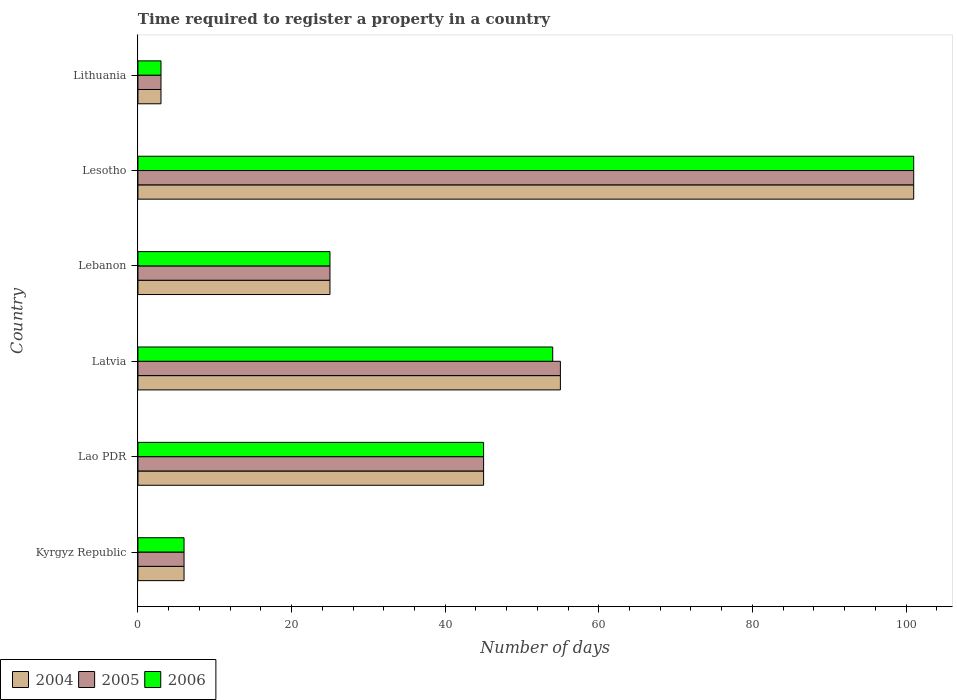How many different coloured bars are there?
Provide a short and direct response. 3. Are the number of bars per tick equal to the number of legend labels?
Offer a very short reply. Yes. Are the number of bars on each tick of the Y-axis equal?
Your response must be concise. Yes. How many bars are there on the 2nd tick from the bottom?
Give a very brief answer. 3. What is the label of the 2nd group of bars from the top?
Your answer should be very brief. Lesotho. In how many cases, is the number of bars for a given country not equal to the number of legend labels?
Give a very brief answer. 0. Across all countries, what is the maximum number of days required to register a property in 2006?
Make the answer very short. 101. Across all countries, what is the minimum number of days required to register a property in 2005?
Keep it short and to the point. 3. In which country was the number of days required to register a property in 2004 maximum?
Give a very brief answer. Lesotho. In which country was the number of days required to register a property in 2005 minimum?
Make the answer very short. Lithuania. What is the total number of days required to register a property in 2005 in the graph?
Offer a terse response. 235. What is the difference between the number of days required to register a property in 2005 in Lithuania and the number of days required to register a property in 2004 in Latvia?
Give a very brief answer. -52. What is the average number of days required to register a property in 2004 per country?
Your answer should be very brief. 39.17. What is the difference between the number of days required to register a property in 2006 and number of days required to register a property in 2004 in Latvia?
Provide a short and direct response. -1. Is the number of days required to register a property in 2004 in Latvia less than that in Lithuania?
Keep it short and to the point. No. Is the difference between the number of days required to register a property in 2006 in Kyrgyz Republic and Lao PDR greater than the difference between the number of days required to register a property in 2004 in Kyrgyz Republic and Lao PDR?
Ensure brevity in your answer.  No. In how many countries, is the number of days required to register a property in 2006 greater than the average number of days required to register a property in 2006 taken over all countries?
Provide a short and direct response. 3. Is the sum of the number of days required to register a property in 2005 in Lao PDR and Latvia greater than the maximum number of days required to register a property in 2006 across all countries?
Give a very brief answer. No. What does the 1st bar from the top in Lesotho represents?
Keep it short and to the point. 2006. What does the 1st bar from the bottom in Lesotho represents?
Offer a very short reply. 2004. How many bars are there?
Keep it short and to the point. 18. Are all the bars in the graph horizontal?
Your answer should be compact. Yes. How many countries are there in the graph?
Give a very brief answer. 6. Does the graph contain any zero values?
Provide a succinct answer. No. Does the graph contain grids?
Your response must be concise. No. How many legend labels are there?
Provide a succinct answer. 3. What is the title of the graph?
Your answer should be very brief. Time required to register a property in a country. Does "2009" appear as one of the legend labels in the graph?
Your response must be concise. No. What is the label or title of the X-axis?
Make the answer very short. Number of days. What is the Number of days of 2004 in Kyrgyz Republic?
Offer a very short reply. 6. What is the Number of days in 2005 in Kyrgyz Republic?
Provide a succinct answer. 6. What is the Number of days of 2006 in Lao PDR?
Provide a short and direct response. 45. What is the Number of days in 2006 in Latvia?
Your response must be concise. 54. What is the Number of days of 2005 in Lebanon?
Provide a succinct answer. 25. What is the Number of days of 2004 in Lesotho?
Your response must be concise. 101. What is the Number of days of 2005 in Lesotho?
Provide a succinct answer. 101. What is the Number of days of 2006 in Lesotho?
Provide a succinct answer. 101. What is the Number of days in 2005 in Lithuania?
Provide a short and direct response. 3. Across all countries, what is the maximum Number of days of 2004?
Ensure brevity in your answer.  101. Across all countries, what is the maximum Number of days in 2005?
Provide a succinct answer. 101. Across all countries, what is the maximum Number of days in 2006?
Your response must be concise. 101. Across all countries, what is the minimum Number of days of 2005?
Your response must be concise. 3. What is the total Number of days in 2004 in the graph?
Provide a short and direct response. 235. What is the total Number of days in 2005 in the graph?
Give a very brief answer. 235. What is the total Number of days of 2006 in the graph?
Keep it short and to the point. 234. What is the difference between the Number of days in 2004 in Kyrgyz Republic and that in Lao PDR?
Offer a very short reply. -39. What is the difference between the Number of days of 2005 in Kyrgyz Republic and that in Lao PDR?
Ensure brevity in your answer.  -39. What is the difference between the Number of days in 2006 in Kyrgyz Republic and that in Lao PDR?
Keep it short and to the point. -39. What is the difference between the Number of days in 2004 in Kyrgyz Republic and that in Latvia?
Offer a very short reply. -49. What is the difference between the Number of days of 2005 in Kyrgyz Republic and that in Latvia?
Provide a short and direct response. -49. What is the difference between the Number of days of 2006 in Kyrgyz Republic and that in Latvia?
Offer a very short reply. -48. What is the difference between the Number of days of 2004 in Kyrgyz Republic and that in Lebanon?
Offer a terse response. -19. What is the difference between the Number of days in 2005 in Kyrgyz Republic and that in Lebanon?
Your response must be concise. -19. What is the difference between the Number of days in 2004 in Kyrgyz Republic and that in Lesotho?
Your answer should be compact. -95. What is the difference between the Number of days in 2005 in Kyrgyz Republic and that in Lesotho?
Give a very brief answer. -95. What is the difference between the Number of days in 2006 in Kyrgyz Republic and that in Lesotho?
Offer a very short reply. -95. What is the difference between the Number of days of 2004 in Kyrgyz Republic and that in Lithuania?
Make the answer very short. 3. What is the difference between the Number of days in 2005 in Kyrgyz Republic and that in Lithuania?
Offer a very short reply. 3. What is the difference between the Number of days in 2006 in Lao PDR and that in Latvia?
Your answer should be very brief. -9. What is the difference between the Number of days in 2005 in Lao PDR and that in Lebanon?
Offer a very short reply. 20. What is the difference between the Number of days of 2004 in Lao PDR and that in Lesotho?
Ensure brevity in your answer.  -56. What is the difference between the Number of days of 2005 in Lao PDR and that in Lesotho?
Give a very brief answer. -56. What is the difference between the Number of days in 2006 in Lao PDR and that in Lesotho?
Provide a succinct answer. -56. What is the difference between the Number of days in 2006 in Lao PDR and that in Lithuania?
Offer a very short reply. 42. What is the difference between the Number of days in 2005 in Latvia and that in Lebanon?
Ensure brevity in your answer.  30. What is the difference between the Number of days of 2004 in Latvia and that in Lesotho?
Ensure brevity in your answer.  -46. What is the difference between the Number of days in 2005 in Latvia and that in Lesotho?
Your answer should be compact. -46. What is the difference between the Number of days in 2006 in Latvia and that in Lesotho?
Keep it short and to the point. -47. What is the difference between the Number of days in 2004 in Lebanon and that in Lesotho?
Provide a succinct answer. -76. What is the difference between the Number of days of 2005 in Lebanon and that in Lesotho?
Keep it short and to the point. -76. What is the difference between the Number of days in 2006 in Lebanon and that in Lesotho?
Provide a succinct answer. -76. What is the difference between the Number of days in 2004 in Lesotho and that in Lithuania?
Ensure brevity in your answer.  98. What is the difference between the Number of days of 2005 in Lesotho and that in Lithuania?
Your answer should be compact. 98. What is the difference between the Number of days of 2006 in Lesotho and that in Lithuania?
Your response must be concise. 98. What is the difference between the Number of days of 2004 in Kyrgyz Republic and the Number of days of 2005 in Lao PDR?
Give a very brief answer. -39. What is the difference between the Number of days in 2004 in Kyrgyz Republic and the Number of days in 2006 in Lao PDR?
Provide a short and direct response. -39. What is the difference between the Number of days of 2005 in Kyrgyz Republic and the Number of days of 2006 in Lao PDR?
Offer a terse response. -39. What is the difference between the Number of days in 2004 in Kyrgyz Republic and the Number of days in 2005 in Latvia?
Provide a succinct answer. -49. What is the difference between the Number of days in 2004 in Kyrgyz Republic and the Number of days in 2006 in Latvia?
Provide a short and direct response. -48. What is the difference between the Number of days of 2005 in Kyrgyz Republic and the Number of days of 2006 in Latvia?
Give a very brief answer. -48. What is the difference between the Number of days in 2004 in Kyrgyz Republic and the Number of days in 2005 in Lebanon?
Ensure brevity in your answer.  -19. What is the difference between the Number of days of 2004 in Kyrgyz Republic and the Number of days of 2006 in Lebanon?
Keep it short and to the point. -19. What is the difference between the Number of days of 2005 in Kyrgyz Republic and the Number of days of 2006 in Lebanon?
Your answer should be compact. -19. What is the difference between the Number of days of 2004 in Kyrgyz Republic and the Number of days of 2005 in Lesotho?
Keep it short and to the point. -95. What is the difference between the Number of days in 2004 in Kyrgyz Republic and the Number of days in 2006 in Lesotho?
Ensure brevity in your answer.  -95. What is the difference between the Number of days in 2005 in Kyrgyz Republic and the Number of days in 2006 in Lesotho?
Give a very brief answer. -95. What is the difference between the Number of days of 2004 in Kyrgyz Republic and the Number of days of 2005 in Lithuania?
Make the answer very short. 3. What is the difference between the Number of days of 2004 in Kyrgyz Republic and the Number of days of 2006 in Lithuania?
Your response must be concise. 3. What is the difference between the Number of days in 2004 in Lao PDR and the Number of days in 2006 in Latvia?
Make the answer very short. -9. What is the difference between the Number of days in 2004 in Lao PDR and the Number of days in 2005 in Lebanon?
Provide a short and direct response. 20. What is the difference between the Number of days of 2005 in Lao PDR and the Number of days of 2006 in Lebanon?
Your response must be concise. 20. What is the difference between the Number of days of 2004 in Lao PDR and the Number of days of 2005 in Lesotho?
Provide a short and direct response. -56. What is the difference between the Number of days of 2004 in Lao PDR and the Number of days of 2006 in Lesotho?
Your answer should be compact. -56. What is the difference between the Number of days in 2005 in Lao PDR and the Number of days in 2006 in Lesotho?
Your response must be concise. -56. What is the difference between the Number of days of 2004 in Lao PDR and the Number of days of 2005 in Lithuania?
Make the answer very short. 42. What is the difference between the Number of days of 2004 in Lao PDR and the Number of days of 2006 in Lithuania?
Offer a terse response. 42. What is the difference between the Number of days in 2005 in Lao PDR and the Number of days in 2006 in Lithuania?
Your answer should be very brief. 42. What is the difference between the Number of days of 2004 in Latvia and the Number of days of 2005 in Lesotho?
Make the answer very short. -46. What is the difference between the Number of days of 2004 in Latvia and the Number of days of 2006 in Lesotho?
Provide a short and direct response. -46. What is the difference between the Number of days of 2005 in Latvia and the Number of days of 2006 in Lesotho?
Give a very brief answer. -46. What is the difference between the Number of days in 2005 in Latvia and the Number of days in 2006 in Lithuania?
Give a very brief answer. 52. What is the difference between the Number of days of 2004 in Lebanon and the Number of days of 2005 in Lesotho?
Give a very brief answer. -76. What is the difference between the Number of days of 2004 in Lebanon and the Number of days of 2006 in Lesotho?
Provide a short and direct response. -76. What is the difference between the Number of days in 2005 in Lebanon and the Number of days in 2006 in Lesotho?
Give a very brief answer. -76. What is the difference between the Number of days of 2004 in Lebanon and the Number of days of 2005 in Lithuania?
Give a very brief answer. 22. What is the difference between the Number of days in 2004 in Lebanon and the Number of days in 2006 in Lithuania?
Provide a short and direct response. 22. What is the difference between the Number of days of 2005 in Lebanon and the Number of days of 2006 in Lithuania?
Keep it short and to the point. 22. What is the difference between the Number of days of 2004 in Lesotho and the Number of days of 2005 in Lithuania?
Keep it short and to the point. 98. What is the difference between the Number of days of 2004 in Lesotho and the Number of days of 2006 in Lithuania?
Give a very brief answer. 98. What is the difference between the Number of days in 2005 in Lesotho and the Number of days in 2006 in Lithuania?
Keep it short and to the point. 98. What is the average Number of days in 2004 per country?
Offer a terse response. 39.17. What is the average Number of days in 2005 per country?
Make the answer very short. 39.17. What is the difference between the Number of days in 2004 and Number of days in 2005 in Lao PDR?
Ensure brevity in your answer.  0. What is the difference between the Number of days of 2004 and Number of days of 2005 in Latvia?
Keep it short and to the point. 0. What is the difference between the Number of days of 2004 and Number of days of 2006 in Latvia?
Provide a succinct answer. 1. What is the difference between the Number of days in 2005 and Number of days in 2006 in Latvia?
Provide a succinct answer. 1. What is the difference between the Number of days of 2004 and Number of days of 2005 in Lesotho?
Provide a succinct answer. 0. What is the difference between the Number of days of 2004 and Number of days of 2006 in Lesotho?
Your answer should be very brief. 0. What is the difference between the Number of days of 2005 and Number of days of 2006 in Lesotho?
Provide a short and direct response. 0. What is the difference between the Number of days of 2004 and Number of days of 2006 in Lithuania?
Ensure brevity in your answer.  0. What is the difference between the Number of days in 2005 and Number of days in 2006 in Lithuania?
Offer a terse response. 0. What is the ratio of the Number of days in 2004 in Kyrgyz Republic to that in Lao PDR?
Offer a very short reply. 0.13. What is the ratio of the Number of days in 2005 in Kyrgyz Republic to that in Lao PDR?
Provide a short and direct response. 0.13. What is the ratio of the Number of days of 2006 in Kyrgyz Republic to that in Lao PDR?
Give a very brief answer. 0.13. What is the ratio of the Number of days in 2004 in Kyrgyz Republic to that in Latvia?
Ensure brevity in your answer.  0.11. What is the ratio of the Number of days of 2005 in Kyrgyz Republic to that in Latvia?
Offer a terse response. 0.11. What is the ratio of the Number of days in 2004 in Kyrgyz Republic to that in Lebanon?
Provide a succinct answer. 0.24. What is the ratio of the Number of days of 2005 in Kyrgyz Republic to that in Lebanon?
Make the answer very short. 0.24. What is the ratio of the Number of days in 2006 in Kyrgyz Republic to that in Lebanon?
Make the answer very short. 0.24. What is the ratio of the Number of days in 2004 in Kyrgyz Republic to that in Lesotho?
Give a very brief answer. 0.06. What is the ratio of the Number of days of 2005 in Kyrgyz Republic to that in Lesotho?
Your answer should be compact. 0.06. What is the ratio of the Number of days in 2006 in Kyrgyz Republic to that in Lesotho?
Your response must be concise. 0.06. What is the ratio of the Number of days of 2005 in Kyrgyz Republic to that in Lithuania?
Keep it short and to the point. 2. What is the ratio of the Number of days of 2004 in Lao PDR to that in Latvia?
Ensure brevity in your answer.  0.82. What is the ratio of the Number of days of 2005 in Lao PDR to that in Latvia?
Ensure brevity in your answer.  0.82. What is the ratio of the Number of days in 2005 in Lao PDR to that in Lebanon?
Offer a very short reply. 1.8. What is the ratio of the Number of days of 2006 in Lao PDR to that in Lebanon?
Provide a succinct answer. 1.8. What is the ratio of the Number of days in 2004 in Lao PDR to that in Lesotho?
Keep it short and to the point. 0.45. What is the ratio of the Number of days of 2005 in Lao PDR to that in Lesotho?
Ensure brevity in your answer.  0.45. What is the ratio of the Number of days of 2006 in Lao PDR to that in Lesotho?
Make the answer very short. 0.45. What is the ratio of the Number of days of 2006 in Lao PDR to that in Lithuania?
Your response must be concise. 15. What is the ratio of the Number of days of 2005 in Latvia to that in Lebanon?
Offer a terse response. 2.2. What is the ratio of the Number of days in 2006 in Latvia to that in Lebanon?
Ensure brevity in your answer.  2.16. What is the ratio of the Number of days of 2004 in Latvia to that in Lesotho?
Ensure brevity in your answer.  0.54. What is the ratio of the Number of days in 2005 in Latvia to that in Lesotho?
Provide a succinct answer. 0.54. What is the ratio of the Number of days of 2006 in Latvia to that in Lesotho?
Provide a short and direct response. 0.53. What is the ratio of the Number of days in 2004 in Latvia to that in Lithuania?
Offer a very short reply. 18.33. What is the ratio of the Number of days of 2005 in Latvia to that in Lithuania?
Give a very brief answer. 18.33. What is the ratio of the Number of days in 2006 in Latvia to that in Lithuania?
Provide a short and direct response. 18. What is the ratio of the Number of days in 2004 in Lebanon to that in Lesotho?
Ensure brevity in your answer.  0.25. What is the ratio of the Number of days of 2005 in Lebanon to that in Lesotho?
Your response must be concise. 0.25. What is the ratio of the Number of days of 2006 in Lebanon to that in Lesotho?
Provide a succinct answer. 0.25. What is the ratio of the Number of days of 2004 in Lebanon to that in Lithuania?
Ensure brevity in your answer.  8.33. What is the ratio of the Number of days of 2005 in Lebanon to that in Lithuania?
Your answer should be very brief. 8.33. What is the ratio of the Number of days in 2006 in Lebanon to that in Lithuania?
Your answer should be very brief. 8.33. What is the ratio of the Number of days in 2004 in Lesotho to that in Lithuania?
Make the answer very short. 33.67. What is the ratio of the Number of days in 2005 in Lesotho to that in Lithuania?
Provide a short and direct response. 33.67. What is the ratio of the Number of days of 2006 in Lesotho to that in Lithuania?
Make the answer very short. 33.67. What is the difference between the highest and the second highest Number of days in 2004?
Offer a very short reply. 46. What is the difference between the highest and the second highest Number of days in 2005?
Provide a short and direct response. 46. What is the difference between the highest and the lowest Number of days in 2004?
Provide a short and direct response. 98. What is the difference between the highest and the lowest Number of days in 2005?
Provide a succinct answer. 98. 